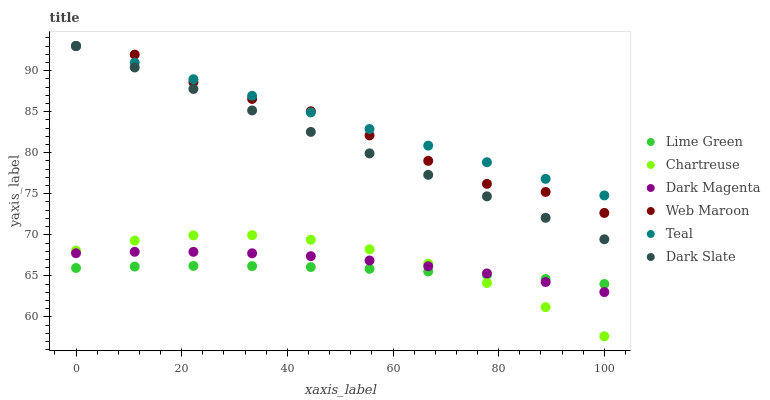Does Lime Green have the minimum area under the curve?
Answer yes or no. Yes. Does Teal have the maximum area under the curve?
Answer yes or no. Yes. Does Web Maroon have the minimum area under the curve?
Answer yes or no. No. Does Web Maroon have the maximum area under the curve?
Answer yes or no. No. Is Teal the smoothest?
Answer yes or no. Yes. Is Web Maroon the roughest?
Answer yes or no. Yes. Is Dark Slate the smoothest?
Answer yes or no. No. Is Dark Slate the roughest?
Answer yes or no. No. Does Chartreuse have the lowest value?
Answer yes or no. Yes. Does Web Maroon have the lowest value?
Answer yes or no. No. Does Teal have the highest value?
Answer yes or no. Yes. Does Chartreuse have the highest value?
Answer yes or no. No. Is Chartreuse less than Teal?
Answer yes or no. Yes. Is Dark Slate greater than Lime Green?
Answer yes or no. Yes. Does Teal intersect Web Maroon?
Answer yes or no. Yes. Is Teal less than Web Maroon?
Answer yes or no. No. Is Teal greater than Web Maroon?
Answer yes or no. No. Does Chartreuse intersect Teal?
Answer yes or no. No. 